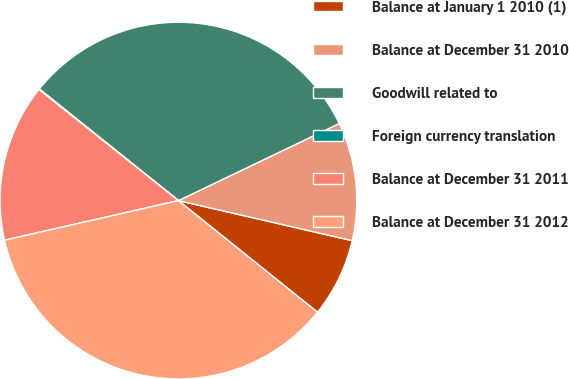Convert chart. <chart><loc_0><loc_0><loc_500><loc_500><pie_chart><fcel>Balance at January 1 2010 (1)<fcel>Balance at December 31 2010<fcel>Goodwill related to<fcel>Foreign currency translation<fcel>Balance at December 31 2011<fcel>Balance at December 31 2012<nl><fcel>7.16%<fcel>10.72%<fcel>32.12%<fcel>0.06%<fcel>14.27%<fcel>35.67%<nl></chart> 